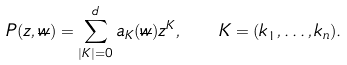Convert formula to latex. <formula><loc_0><loc_0><loc_500><loc_500>P ( z , \overline { w } ) = \sum _ { | K | = 0 } ^ { d } { a _ { K } ( \overline { w } ) z ^ { K } } , \ \ K = ( k _ { 1 } , \dots , k _ { n } ) .</formula> 